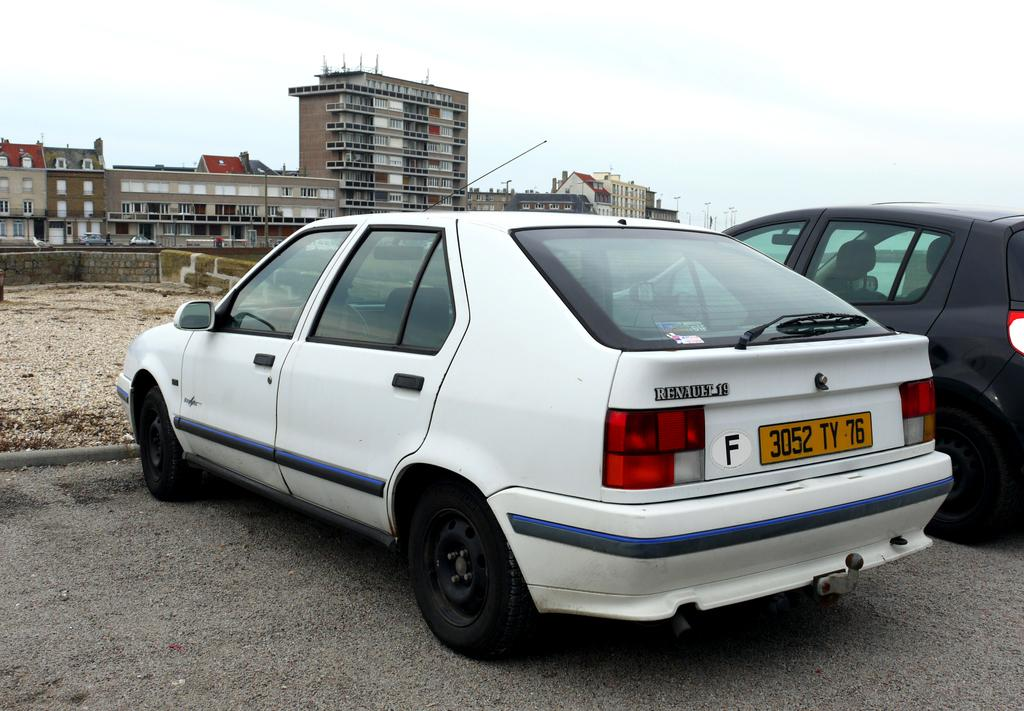What can be seen in the foreground of the image? There are two cars in the foreground of the image. Where are the cars located? The cars are on the road. What can be seen in the background of the image? There is land, buildings, and the sky visible in the background of the image. What type of coal is being delivered to the buildings in the image? There is no coal or delivery mentioned in the image; it only shows two cars on the road and buildings in the background. 